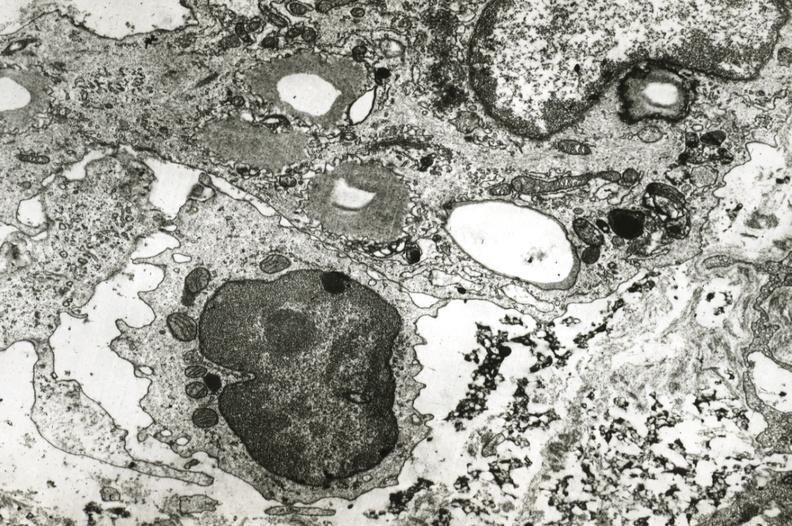s vasculature present?
Answer the question using a single word or phrase. Yes 